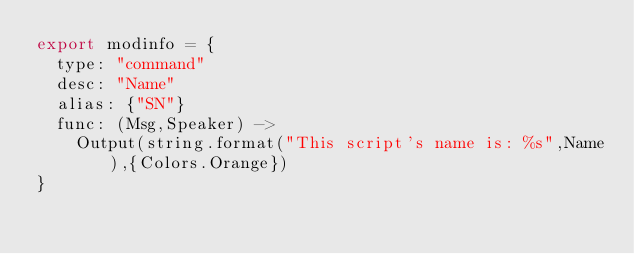Convert code to text. <code><loc_0><loc_0><loc_500><loc_500><_MoonScript_>export modinfo = {
	type: "command"
	desc: "Name"
	alias: {"SN"}
	func: (Msg,Speaker) ->
		Output(string.format("This script's name is: %s",Name),{Colors.Orange})
}</code> 